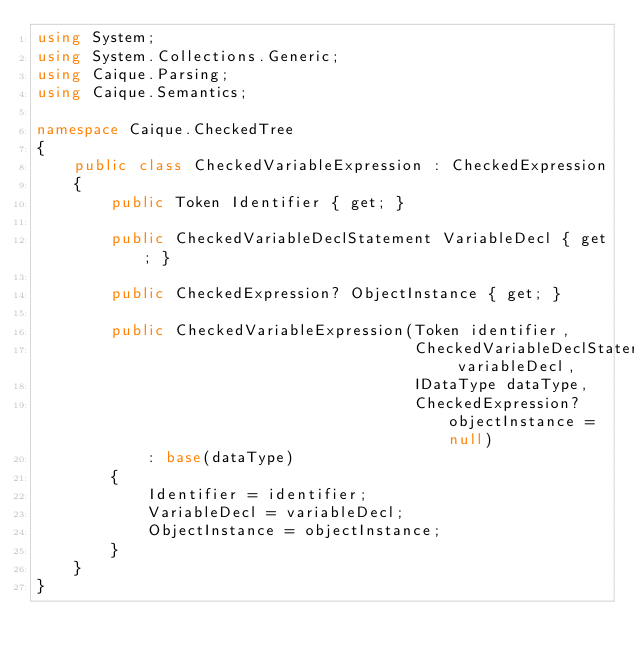Convert code to text. <code><loc_0><loc_0><loc_500><loc_500><_C#_>using System;
using System.Collections.Generic;
using Caique.Parsing;
using Caique.Semantics;

namespace Caique.CheckedTree
{
    public class CheckedVariableExpression : CheckedExpression
    {
        public Token Identifier { get; }

        public CheckedVariableDeclStatement VariableDecl { get; }

        public CheckedExpression? ObjectInstance { get; }

        public CheckedVariableExpression(Token identifier,
                                         CheckedVariableDeclStatement variableDecl,
                                         IDataType dataType,
                                         CheckedExpression? objectInstance = null)
            : base(dataType)
        {
            Identifier = identifier;
            VariableDecl = variableDecl;
            ObjectInstance = objectInstance;
        }
    }
}</code> 